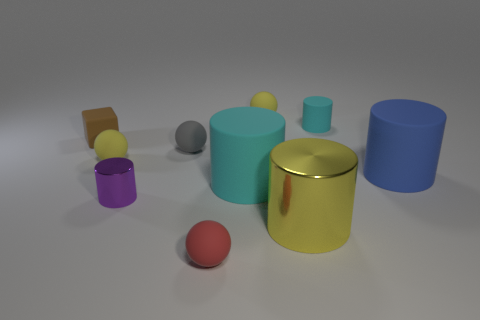What is the tiny yellow sphere that is to the left of the tiny yellow matte sphere behind the tiny yellow rubber thing to the left of the tiny red sphere made of? rubber 